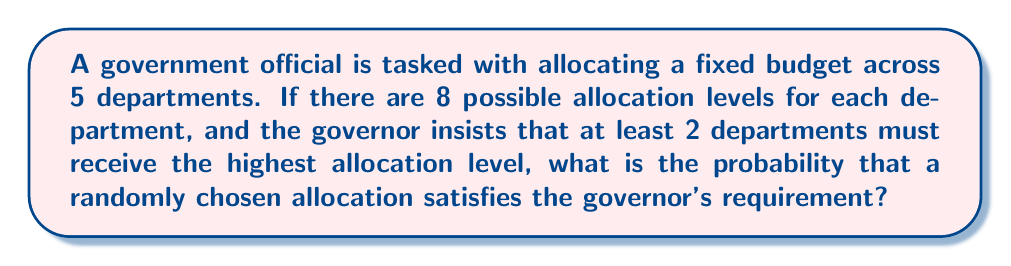Help me with this question. Let's approach this step-by-step:

1) First, we need to calculate the total number of possible allocations:
   $$ \text{Total allocations} = 8^5 $$
   This is because each of the 5 departments has 8 choices.

2) Now, we need to calculate the number of favorable allocations (those with at least 2 departments receiving the highest allocation):

   a) Let's use the complementary counting method. It's easier to count allocations that don't meet the requirement and subtract from the total.

   b) Allocations that don't meet the requirement:
      - 0 departments with highest allocation: $7^5$
      - 1 department with highest allocation: $\binom{5}{1} \cdot 1 \cdot 7^4$

   c) Therefore, favorable allocations:
      $$ \text{Favorable} = 8^5 - (7^5 + \binom{5}{1} \cdot 1 \cdot 7^4) $$

3) The probability is then:

   $$ P(\text{at least 2 highest}) = \frac{\text{Favorable allocations}}{\text{Total allocations}} $$

   $$ = \frac{8^5 - (7^5 + 5 \cdot 7^4)}{8^5} $$

   $$ = 1 - \frac{7^5 + 5 \cdot 7^4}{8^5} $$

   $$ = 1 - (\frac{7}{8})^5 - 5 \cdot \frac{7^4}{8^5} $$

   $$ = 1 - (\frac{7}{8})^5 - \frac{5 \cdot 7^4}{8^5} $$

4) Calculating this:
   $$ = 1 - 0.4670 - 0.2384 = 0.2946 $$
Answer: $0.2946$ or $29.46\%$ 